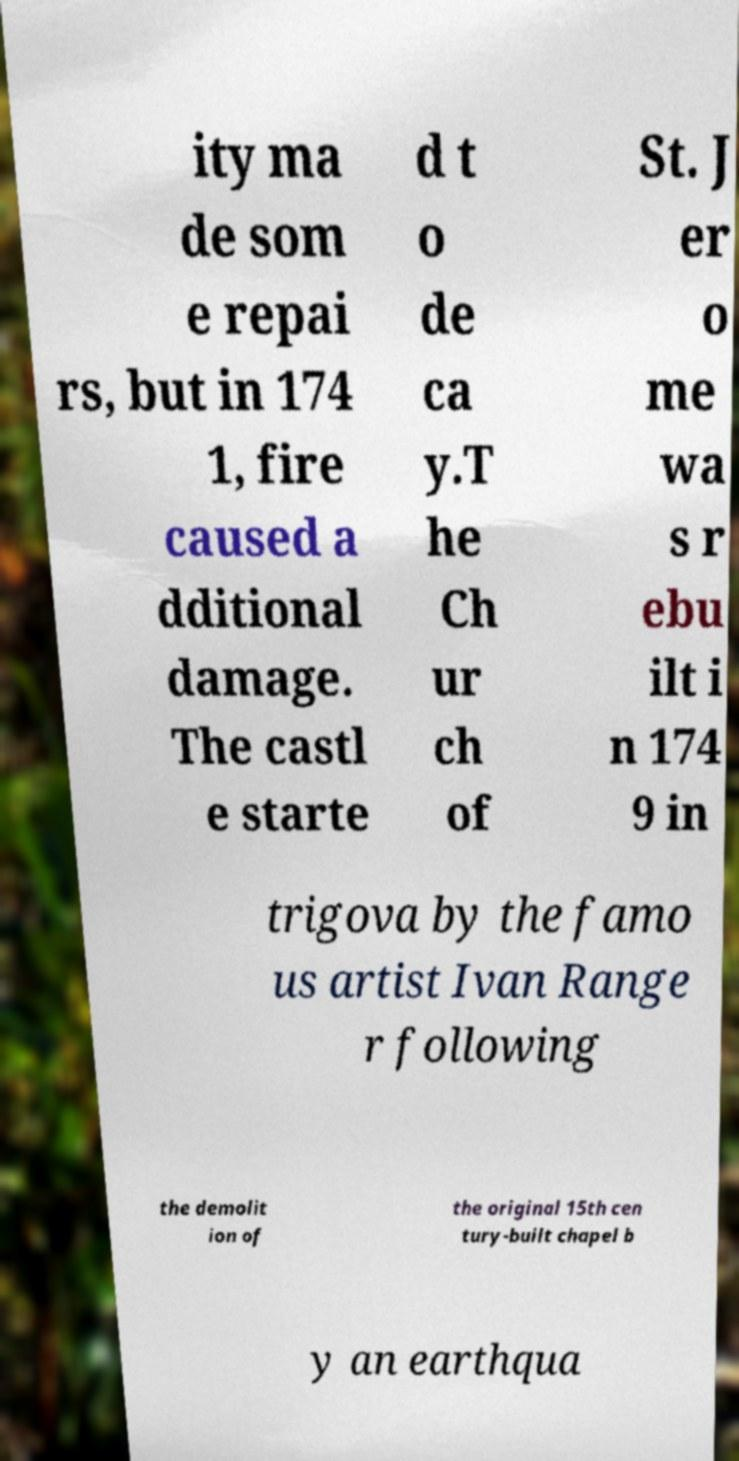Can you read and provide the text displayed in the image?This photo seems to have some interesting text. Can you extract and type it out for me? ity ma de som e repai rs, but in 174 1, fire caused a dditional damage. The castl e starte d t o de ca y.T he Ch ur ch of St. J er o me wa s r ebu ilt i n 174 9 in trigova by the famo us artist Ivan Range r following the demolit ion of the original 15th cen tury-built chapel b y an earthqua 